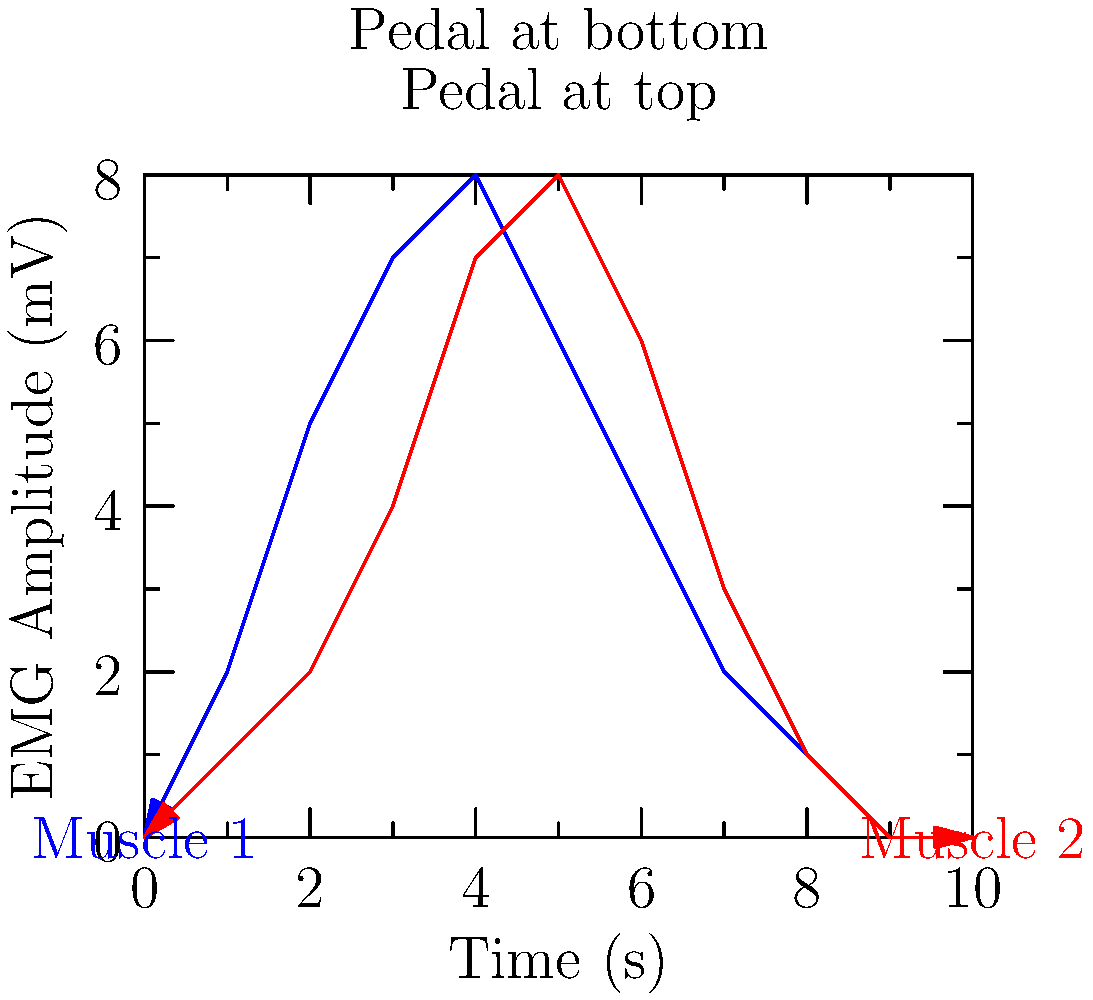Given the EMG signal plots for two muscles during a cycling motion, which muscle is likely to be the quadriceps, and how does its activation pattern relate to the pedal position in the cycling motion? To answer this question, we need to analyze the EMG signal patterns and their relationship to the cycling motion:

1. The blue line (Muscle 1) shows higher activation early in the cycle, peaking around 4 seconds.
2. The red line (Muscle 2) shows higher activation later in the cycle, peaking around 5-6 seconds.
3. In a typical cycling motion, the quadriceps are most active during the downstroke, when the pedal moves from the top position to the bottom position.
4. The pedal positions are marked on the graph, with the top position at 3 seconds and the bottom position at 7 seconds.
5. Muscle 1 (blue) shows peak activation between the top and bottom pedal positions, which aligns with the expected activation pattern of the quadriceps during the downstroke.
6. Muscle 2 (red) shows peak activation after the pedal has passed the bottom position, which is more consistent with muscles involved in the upstroke (e.g., hamstrings or hip flexors).

Therefore, Muscle 1 (blue line) is likely to be the quadriceps. Its activation pattern shows highest activity during the downstroke phase of the pedal motion, which is when the quadriceps are primarily engaged to extend the knee and push the pedal down.
Answer: Muscle 1 (blue); peaks during downstroke 